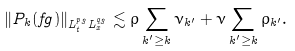<formula> <loc_0><loc_0><loc_500><loc_500>\| P _ { k } ( f g ) \| _ { L ^ { p _ { 3 } } _ { t } L ^ { q _ { 3 } } _ { x } } \lesssim \rho \sum _ { k ^ { \prime } \geq k } \nu _ { k ^ { \prime } } + \nu \sum _ { k ^ { \prime } \geq k } \rho _ { k ^ { \prime } } .</formula> 